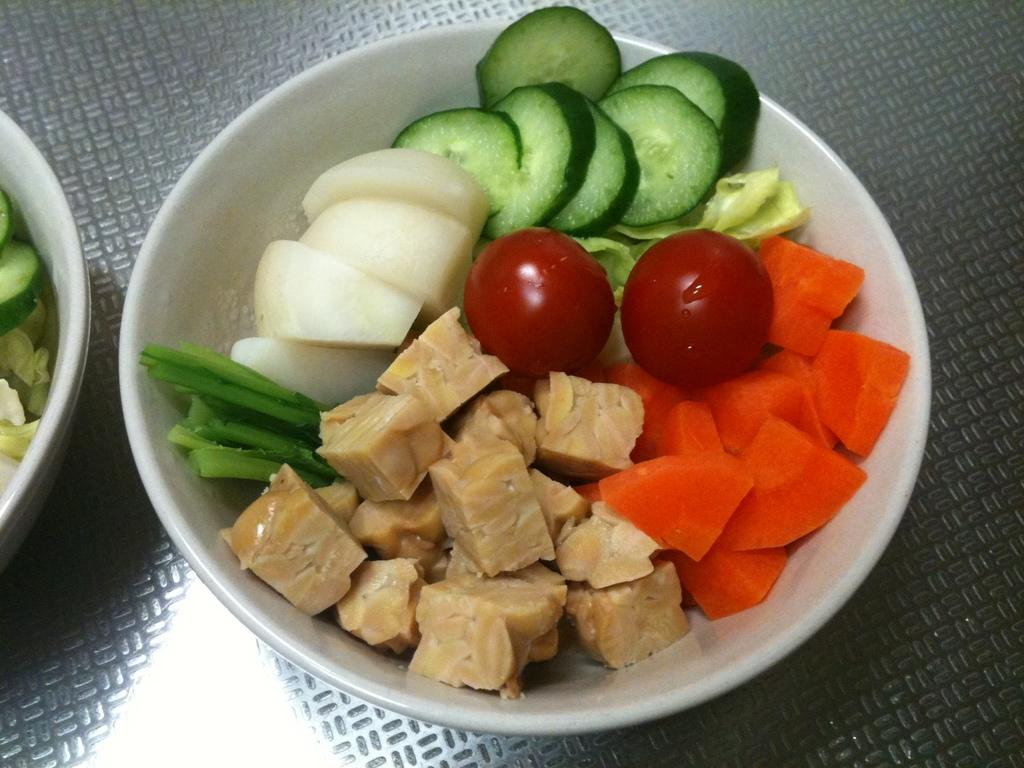What type of food is in the bowls in the image? There are vegetables in the bowls in the image. What color are the bowls? The bowls are white in color. What type of material is the floor in the image made of? The floor in the image is made of metal. What is the desire of the vegetables in the image? The vegetables in the image do not have desires, as they are inanimate objects. 